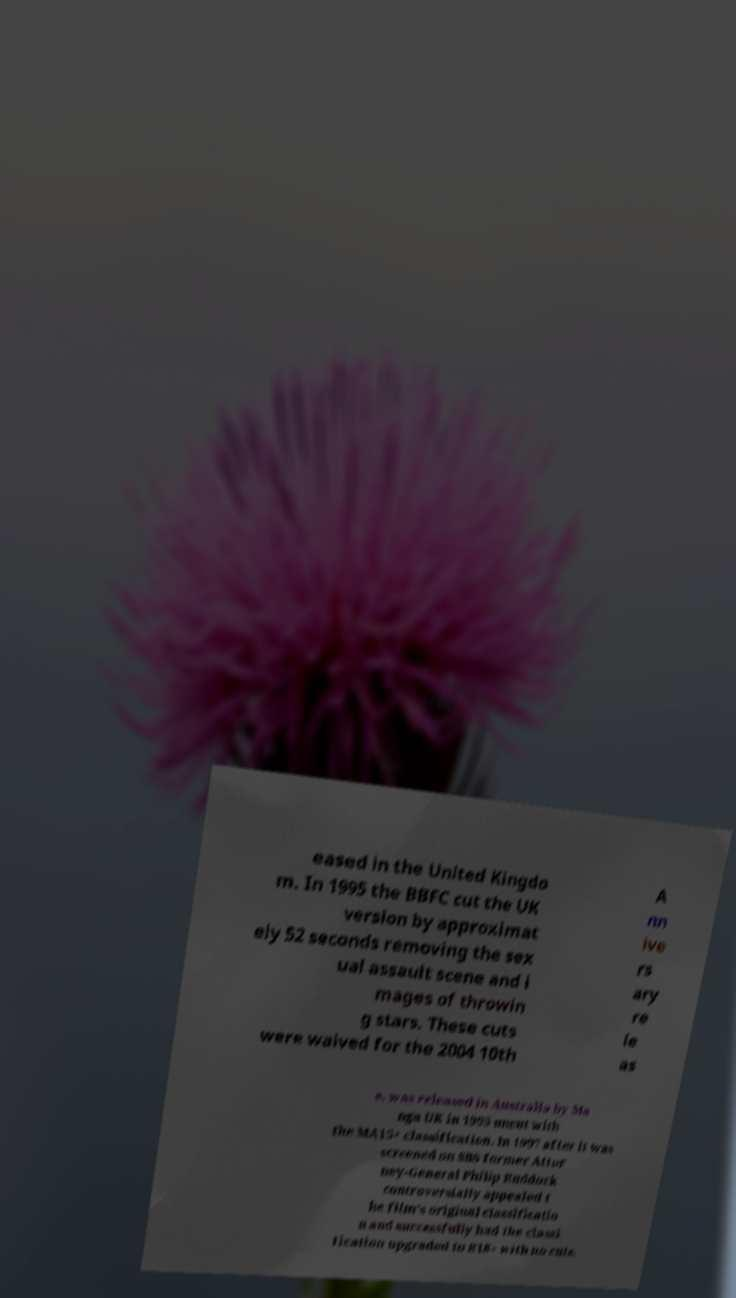Could you assist in decoding the text presented in this image and type it out clearly? eased in the United Kingdo m. In 1995 the BBFC cut the UK version by approximat ely 52 seconds removing the sex ual assault scene and i mages of throwin g stars. These cuts were waived for the 2004 10th A nn ive rs ary re le as e. was released in Australia by Ma nga UK in 1995 uncut with the MA15+ classification. In 1997 after it was screened on SBS former Attor ney-General Philip Ruddock controversially appealed t he film's original classificatio n and successfully had the classi fication upgraded to R18+ with no cuts. 